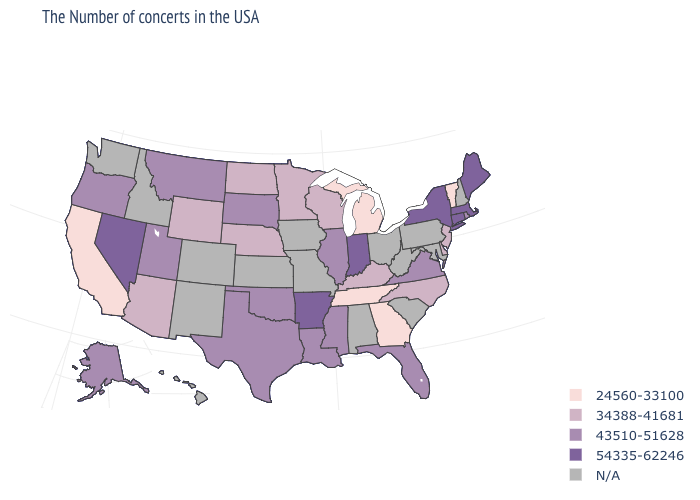Among the states that border Colorado , does Nebraska have the lowest value?
Answer briefly. Yes. What is the highest value in the USA?
Give a very brief answer. 54335-62246. What is the value of Arkansas?
Quick response, please. 54335-62246. Which states hav the highest value in the West?
Write a very short answer. Nevada. Which states have the lowest value in the Northeast?
Keep it brief. Vermont. What is the lowest value in the USA?
Be succinct. 24560-33100. Does Nevada have the highest value in the West?
Concise answer only. Yes. What is the lowest value in the USA?
Give a very brief answer. 24560-33100. What is the lowest value in the South?
Quick response, please. 24560-33100. Does the map have missing data?
Give a very brief answer. Yes. Among the states that border New Hampshire , does Maine have the lowest value?
Short answer required. No. What is the value of Maine?
Quick response, please. 54335-62246. Which states hav the highest value in the Northeast?
Concise answer only. Maine, Massachusetts, Connecticut, New York. 